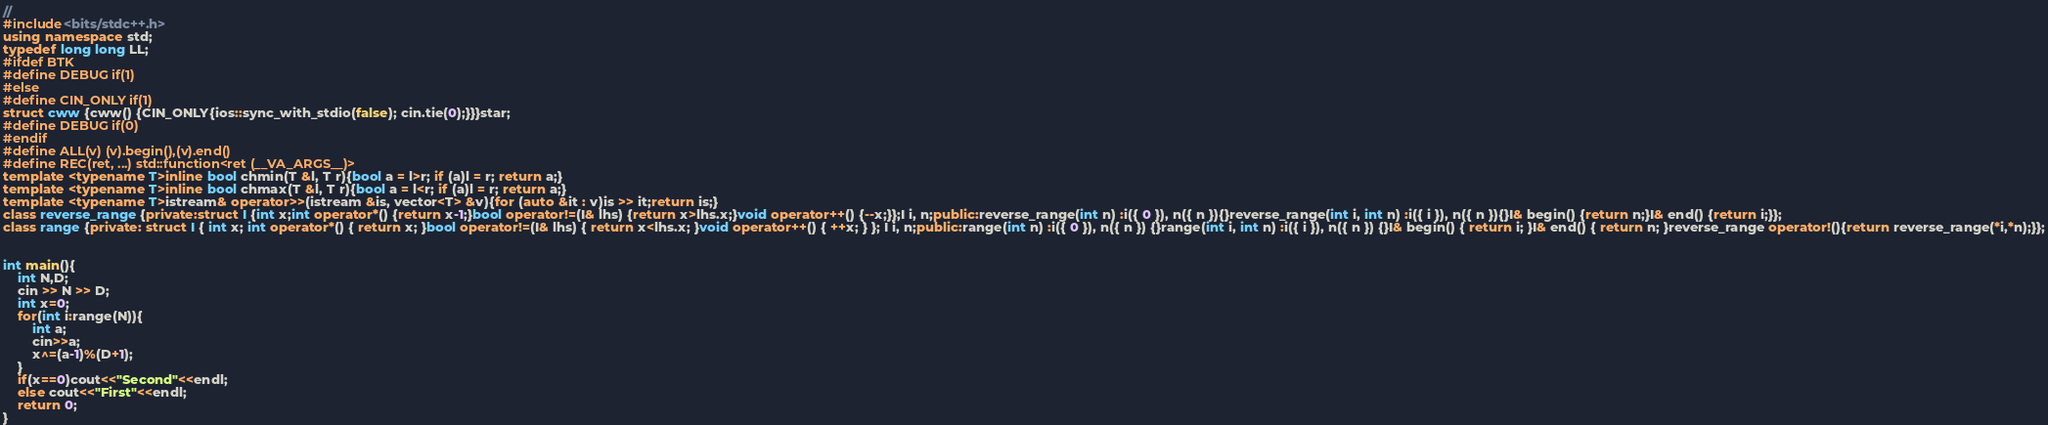Convert code to text. <code><loc_0><loc_0><loc_500><loc_500><_C++_>//
#include<bits/stdc++.h>
using namespace std;
typedef long long LL;
#ifdef BTK
#define DEBUG if(1)
#else
#define CIN_ONLY if(1)
struct cww {cww() {CIN_ONLY{ios::sync_with_stdio(false); cin.tie(0);}}}star;
#define DEBUG if(0)
#endif
#define ALL(v) (v).begin(),(v).end()
#define REC(ret, ...) std::function<ret (__VA_ARGS__)>
template <typename T>inline bool chmin(T &l, T r){bool a = l>r; if (a)l = r; return a;}
template <typename T>inline bool chmax(T &l, T r){bool a = l<r; if (a)l = r; return a;}
template <typename T>istream& operator>>(istream &is, vector<T> &v){for (auto &it : v)is >> it;return is;}
class reverse_range {private:struct I {int x;int operator*() {return x-1;}bool operator!=(I& lhs) {return x>lhs.x;}void operator++() {--x;}};I i, n;public:reverse_range(int n) :i({ 0 }), n({ n }){}reverse_range(int i, int n) :i({ i }), n({ n }){}I& begin() {return n;}I& end() {return i;}};
class range {private: struct I { int x; int operator*() { return x; }bool operator!=(I& lhs) { return x<lhs.x; }void operator++() { ++x; } }; I i, n;public:range(int n) :i({ 0 }), n({ n }) {}range(int i, int n) :i({ i }), n({ n }) {}I& begin() { return i; }I& end() { return n; }reverse_range operator!(){return reverse_range(*i,*n);}};


int main(){
    int N,D;
    cin >> N >> D;
    int x=0;
    for(int i:range(N)){
        int a;
        cin>>a;
        x^=(a-1)%(D+1);
    }
    if(x==0)cout<<"Second"<<endl;
    else cout<<"First"<<endl;
    return 0;
}
</code> 